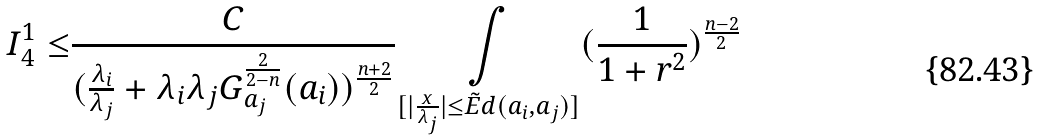Convert formula to latex. <formula><loc_0><loc_0><loc_500><loc_500>I _ { 4 } ^ { 1 } \leq & \frac { C } { ( \frac { \lambda _ { i } } { \lambda _ { j } } + \lambda _ { i } \lambda _ { j } G ^ { \frac { 2 } { 2 - n } } _ { a _ { j } } ( a _ { i } ) ) ^ { \frac { n + 2 } { 2 } } } \underset { [ | \frac { x } { \lambda _ { j } } | \leq \tilde { E } d ( a _ { i } , a _ { j } ) ] } { \int } ( \frac { 1 } { 1 + r ^ { 2 } } ) ^ { \frac { n - 2 } { 2 } }</formula> 